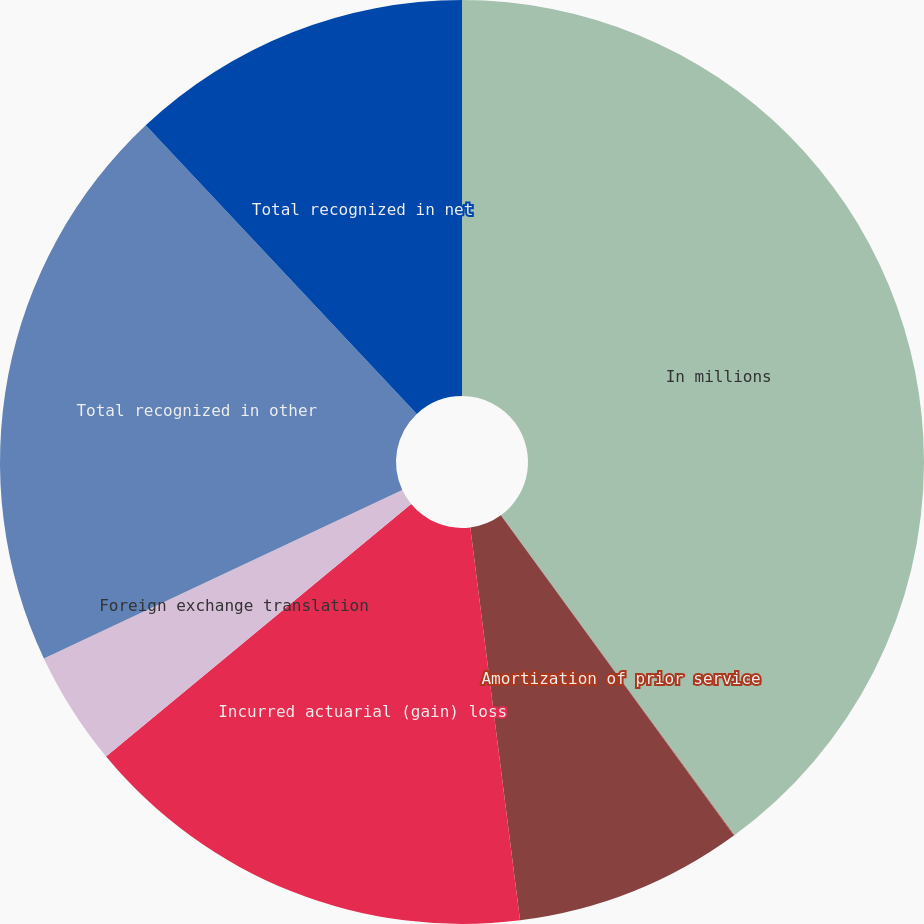<chart> <loc_0><loc_0><loc_500><loc_500><pie_chart><fcel>In millions<fcel>Amortization of prior service<fcel>Recognized actuarial loss<fcel>Incurred actuarial (gain) loss<fcel>Foreign exchange translation<fcel>Total recognized in other<fcel>Total recognized in net<nl><fcel>39.96%<fcel>0.02%<fcel>8.01%<fcel>16.0%<fcel>4.01%<fcel>19.99%<fcel>12.0%<nl></chart> 